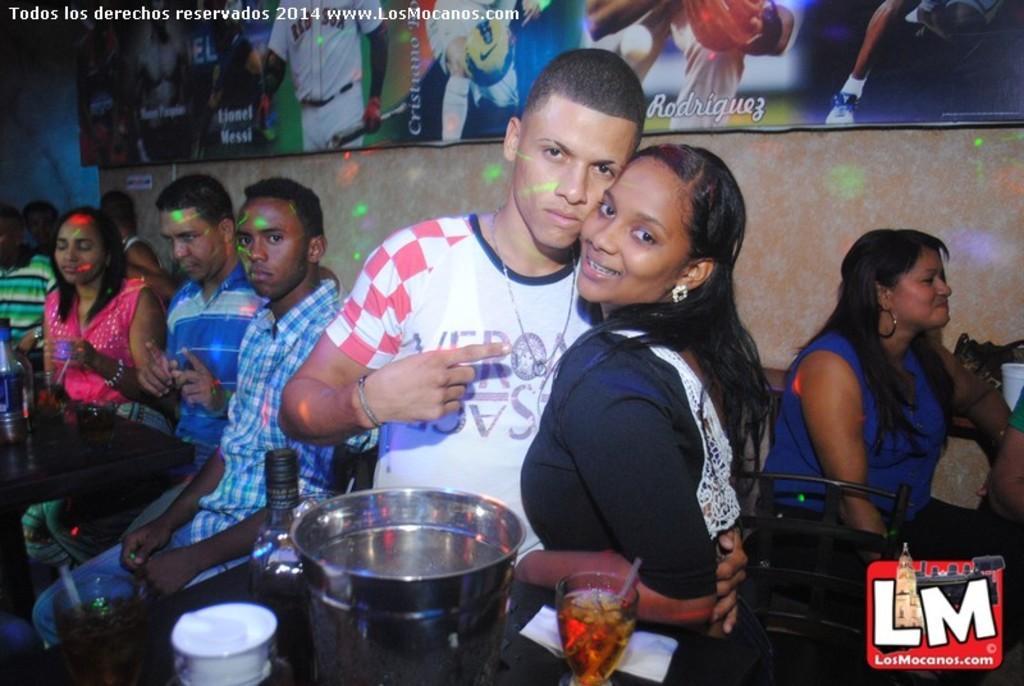Please provide a concise description of this image. In this image we can see some people in a room and among them two people are standing and posing for a photo. There are some tables and we can see objects like glasses, bottle and some other things on the table. We can see a wall in the background with a poster and on the poster there are some pictures. 